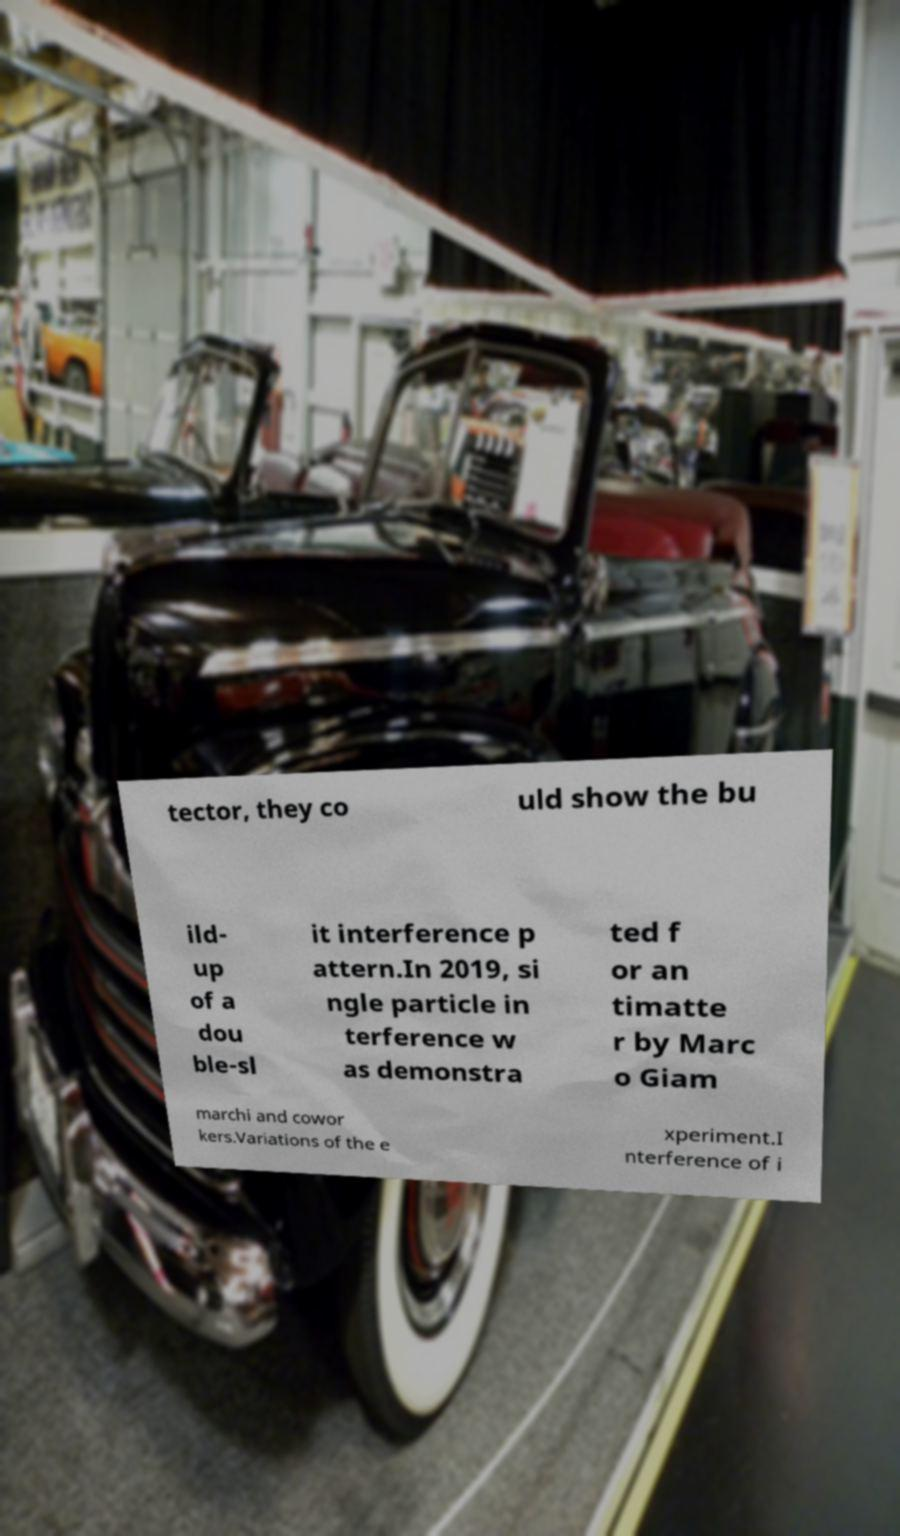What messages or text are displayed in this image? I need them in a readable, typed format. tector, they co uld show the bu ild- up of a dou ble-sl it interference p attern.In 2019, si ngle particle in terference w as demonstra ted f or an timatte r by Marc o Giam marchi and cowor kers.Variations of the e xperiment.I nterference of i 